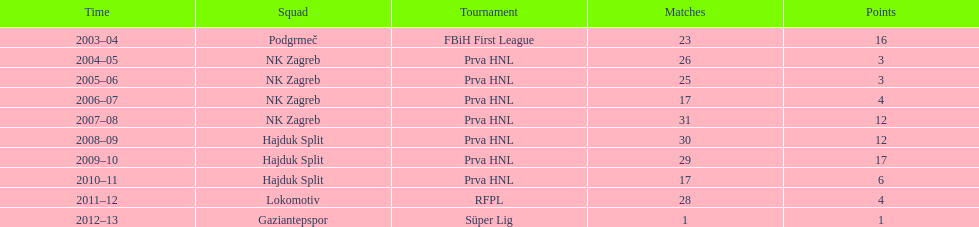Did ibricic score more or less goals in his 3 seasons with hajduk split when compared to his 4 seasons with nk zagreb? More. 